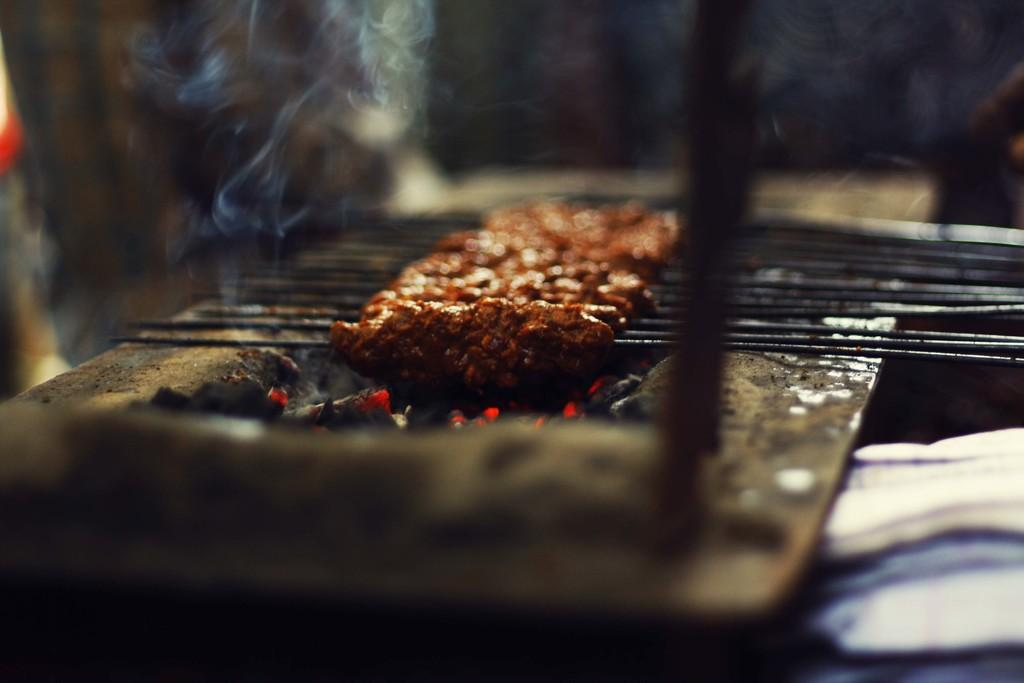What type of cooking is being done in the image? There is a barbecue-style cooking in the image. What is being used as the heat source for the cooking? The cooking is being done on burning coal. How is the coal arranged for the cooking? The coal is placed on a platform. What can be observed as a result of the burning coal? Smoke is visible in the image. Can you describe the background of the image? The background of the image is not clear to describe. How many cakes are being decorated with a pin in the image? There are no cakes or pins present in the image; it features barbecue-style cooking on burning coal. 